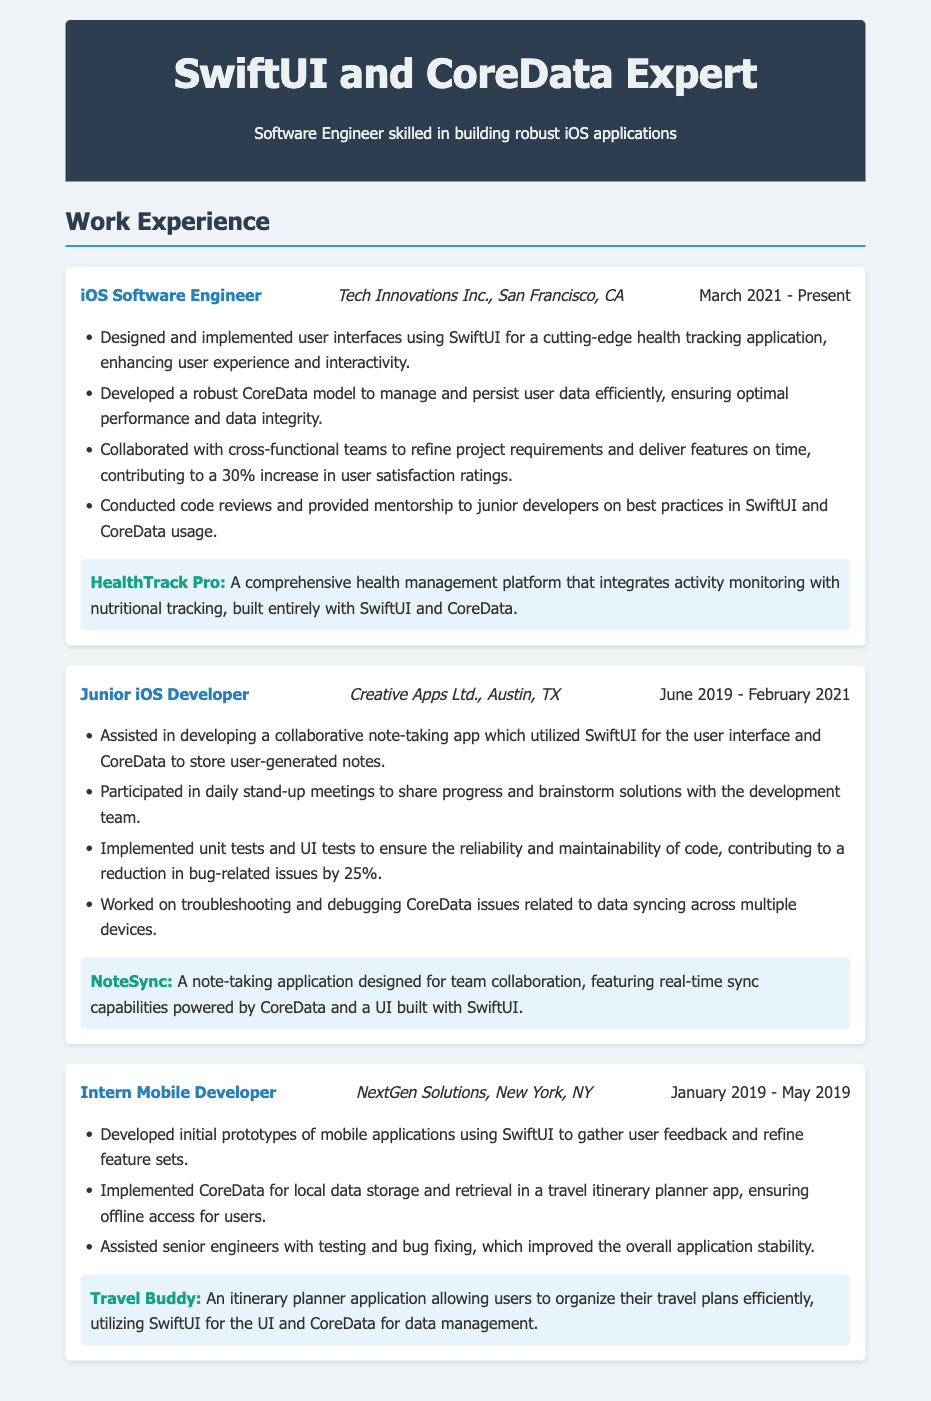what is the title of the current position? The title of the current position listed in the document is "iOS Software Engineer."
Answer: iOS Software Engineer where is the current job located? The current job is located at "Tech Innovations Inc., San Francisco, CA."
Answer: San Francisco, CA what is the start date of the current position? The start date of the current position is listed as "March 2021."
Answer: March 2021 how many years of experience does the individual have in iOS development at the time of the resume? The total experience can be calculated from the positions mentioned: March 2021 to Present, June 2019 to February 2021, and January 2019 to May 2019, totaling to approximately 3 years of experience in iOS development.
Answer: 3 years name one project that utilized SwiftUI and CoreData in the current position. The project listed in the current position that utilized SwiftUI and CoreData is "HealthTrack Pro."
Answer: HealthTrack Pro in which position did the individual participate in daily stand-up meetings? The position where the individual participated in daily stand-up meetings is "Junior iOS Developer."
Answer: Junior iOS Developer which application allowed users to organize their travel plans? The application that allowed users to organize their travel plans is "Travel Buddy."
Answer: Travel Buddy what type of testing was implemented to ensure code reliability? The types of testing implemented for code reliability are "unit tests and UI tests."
Answer: unit tests and UI tests who mentored junior developers on best practices? The individual who mentored junior developers on best practices is identified in the "iOS Software Engineer" role.
Answer: iOS Software Engineer 